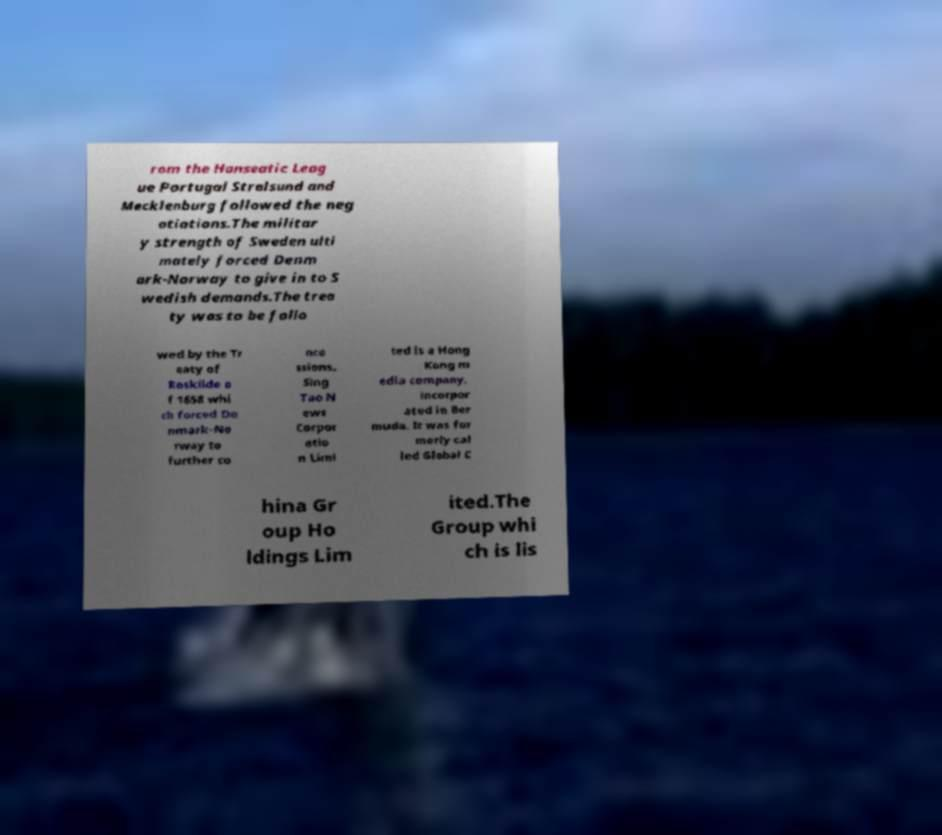Please read and relay the text visible in this image. What does it say? rom the Hanseatic Leag ue Portugal Stralsund and Mecklenburg followed the neg otiations.The militar y strength of Sweden ulti mately forced Denm ark-Norway to give in to S wedish demands.The trea ty was to be follo wed by the Tr eaty of Roskilde o f 1658 whi ch forced De nmark-No rway to further co nce ssions. Sing Tao N ews Corpor atio n Limi ted is a Hong Kong m edia company, incorpor ated in Ber muda. It was for merly cal led Global C hina Gr oup Ho ldings Lim ited.The Group whi ch is lis 